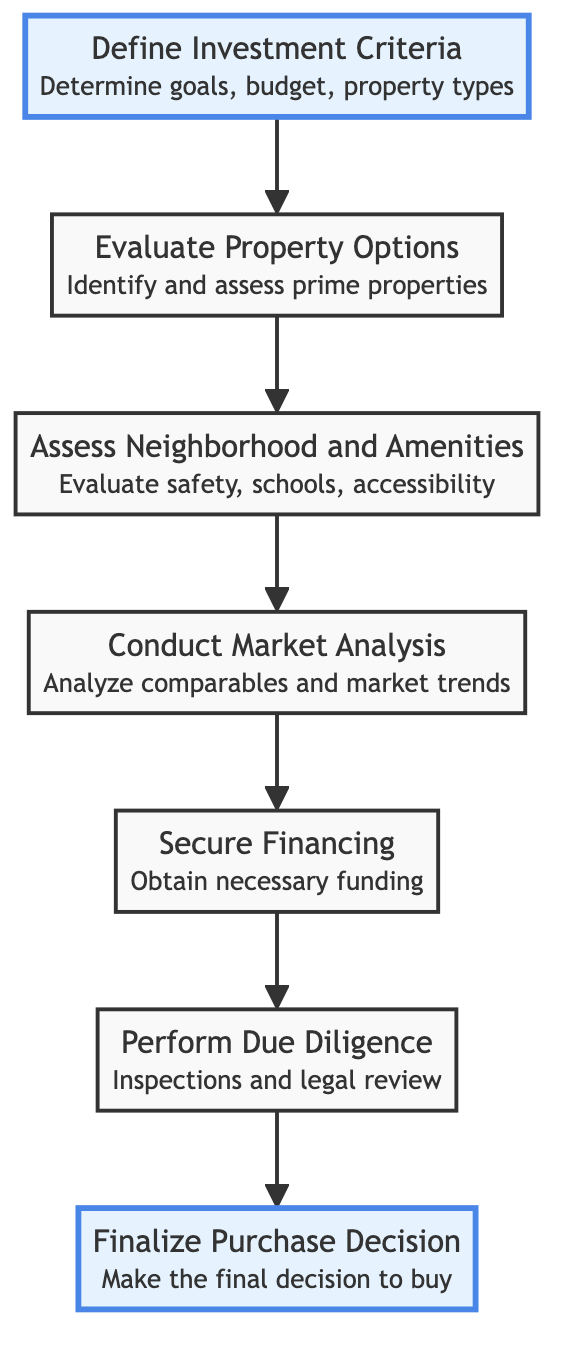What is the first step in the process? The diagram starts with "Define Investment Criteria," which is labeled as the first step, clearly presented at the bottom of the flowchart.
Answer: Define Investment Criteria How many steps are in the process? The flowchart lists seven distinct steps including "Define Investment Criteria" to "Finalize Purchase Decision," which can be counted easily in the diagram.
Answer: Seven What comes after "Assess Neighborhood and Amenities"? According to the sequence in the diagram, "Conduct Market Analysis" is the next step that follows "Assess Neighborhood and Amenities."
Answer: Conduct Market Analysis What is the final step before buying a property? The last step before making a purchase is "Perform Due Diligence," which occurs just before the final decision is made to buy the property.
Answer: Perform Due Diligence What type of information is evaluated in "Evaluate Property Options"? The step "Evaluate Property Options" involves assessing properties based on criteria like location, price, and investment potential, as indicated in the description of that step in the diagram.
Answer: Location, price, investment potential Which two steps are highlighted in the diagram? The steps highlighted in the diagram are "Define Investment Criteria" at the bottom and "Finalize Purchase Decision" at the top, which emphasize the critical starting and ending points of the investment process.
Answer: Define Investment Criteria, Finalize Purchase Decision What precedes "Secure Financing"? "Conduct Market Analysis" is the step that comes immediately before "Secure Financing," indicating the need to analyze the market conditions prior to obtaining funding.
Answer: Conduct Market Analysis What is necessary to confirm before making a purchase decision? The step "Perform Due Diligence" is necessary to ensure that inspections, legal document reviews, and property condition confirmations are completed before finalizing any purchase.
Answer: Due Diligence What is the last action taken in the flowchart? The last action in the flowchart is "Finalize Purchase Decision," which indicates the conclusion of the property investment process.
Answer: Finalize Purchase Decision 